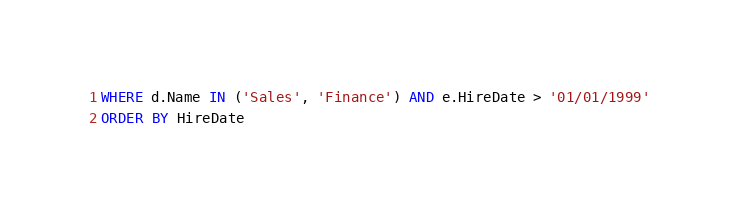<code> <loc_0><loc_0><loc_500><loc_500><_SQL_>WHERE d.Name IN ('Sales', 'Finance') AND e.HireDate > '01/01/1999'
ORDER BY HireDate</code> 